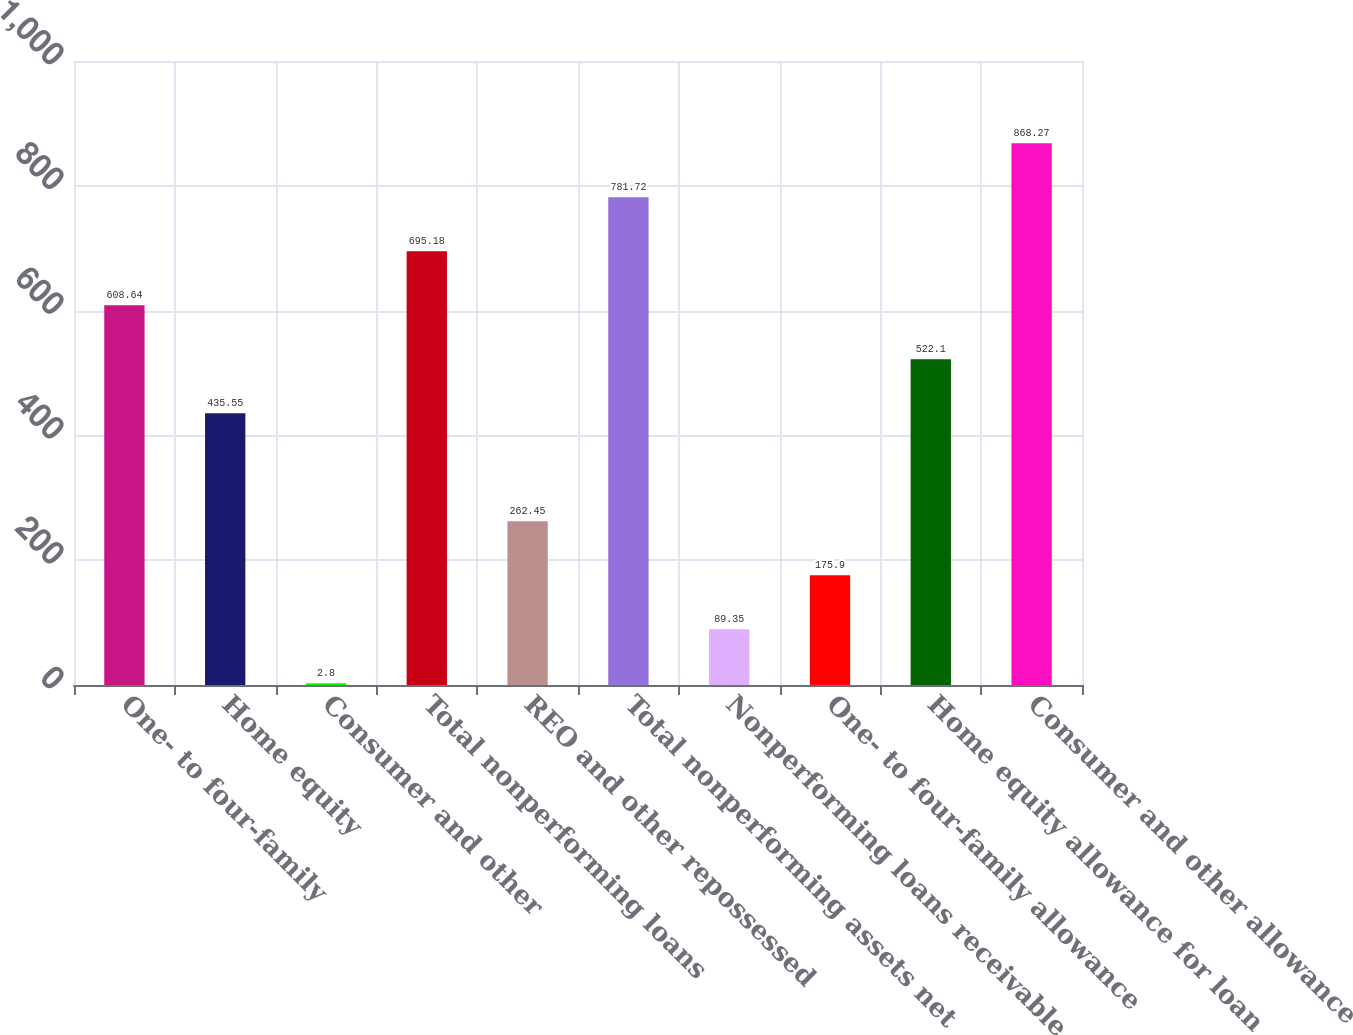<chart> <loc_0><loc_0><loc_500><loc_500><bar_chart><fcel>One- to four-family<fcel>Home equity<fcel>Consumer and other<fcel>Total nonperforming loans<fcel>REO and other repossessed<fcel>Total nonperforming assets net<fcel>Nonperforming loans receivable<fcel>One- to four-family allowance<fcel>Home equity allowance for loan<fcel>Consumer and other allowance<nl><fcel>608.64<fcel>435.55<fcel>2.8<fcel>695.18<fcel>262.45<fcel>781.72<fcel>89.35<fcel>175.9<fcel>522.1<fcel>868.27<nl></chart> 